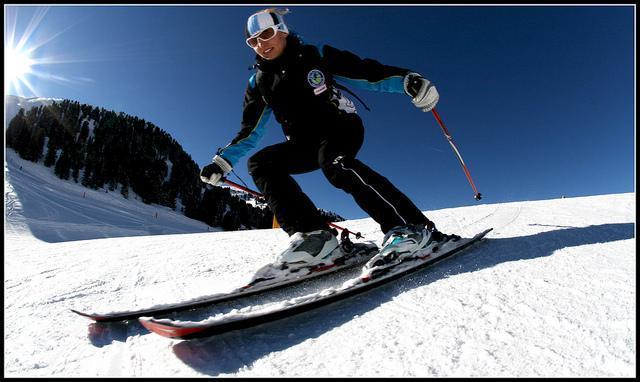How many of these bottles have yellow on the lid?
Give a very brief answer. 0. 